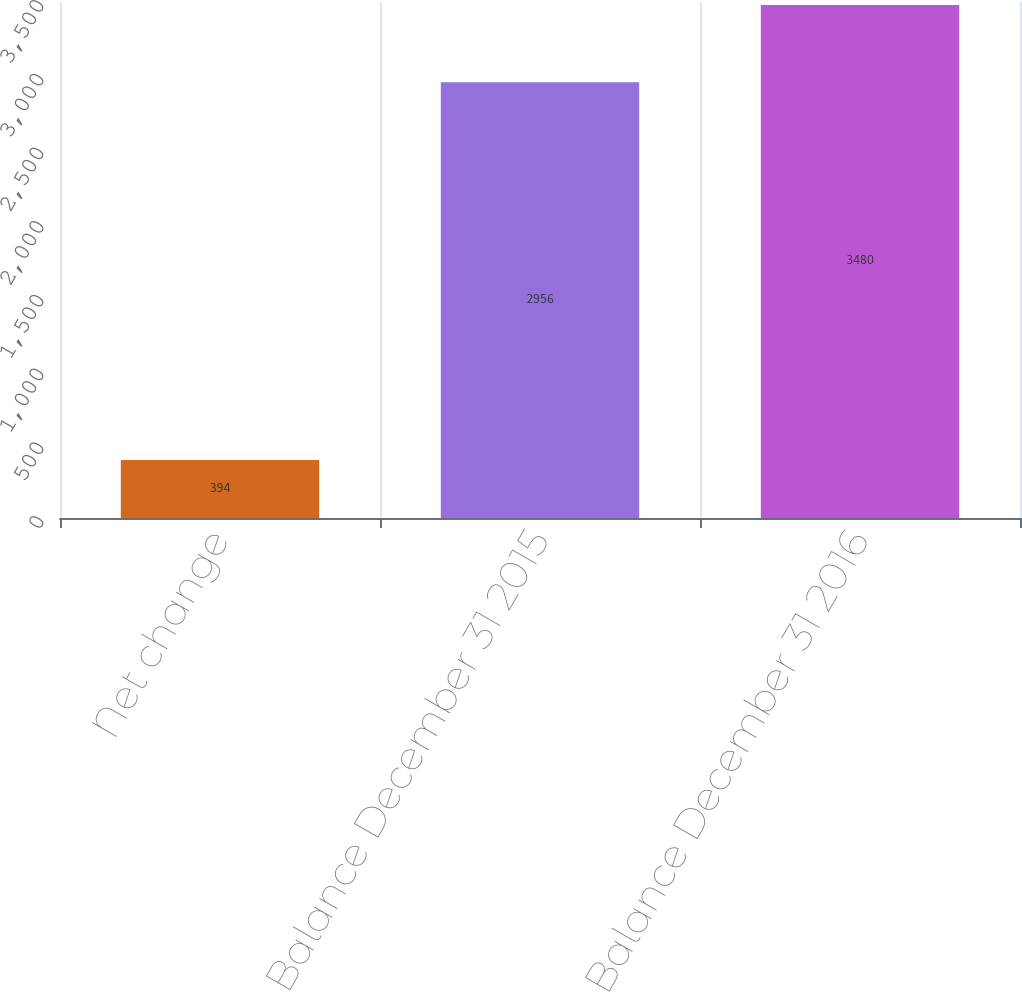<chart> <loc_0><loc_0><loc_500><loc_500><bar_chart><fcel>Net change<fcel>Balance December 31 2015<fcel>Balance December 31 2016<nl><fcel>394<fcel>2956<fcel>3480<nl></chart> 